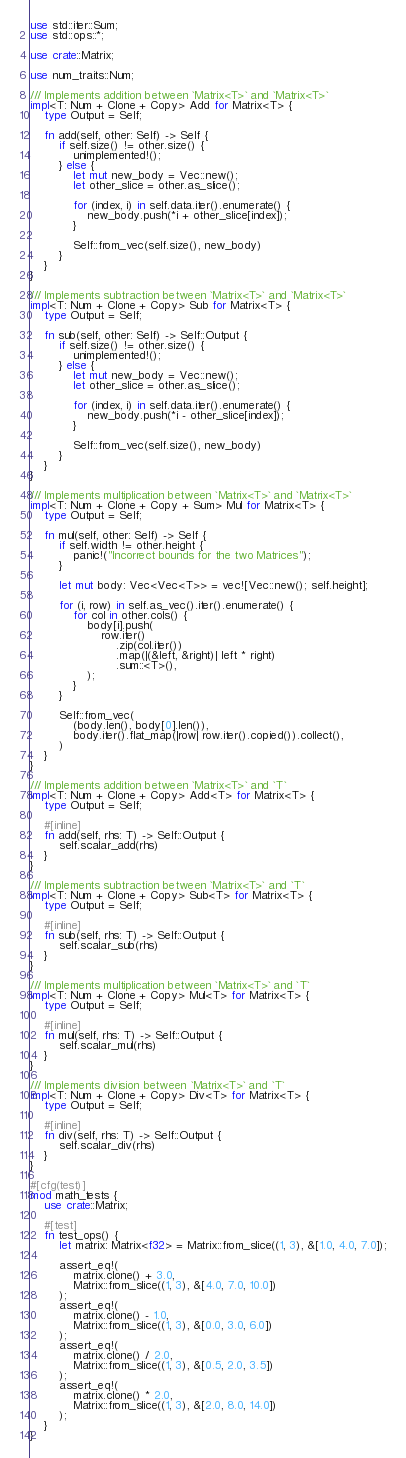<code> <loc_0><loc_0><loc_500><loc_500><_Rust_>use std::iter::Sum;
use std::ops::*;

use crate::Matrix;

use num_traits::Num;

/// Implements addition between `Matrix<T>` and `Matrix<T>`
impl<T: Num + Clone + Copy> Add for Matrix<T> {
    type Output = Self;

    fn add(self, other: Self) -> Self {
        if self.size() != other.size() {
            unimplemented!();
        } else {
            let mut new_body = Vec::new();
            let other_slice = other.as_slice();

            for (index, i) in self.data.iter().enumerate() {
                new_body.push(*i + other_slice[index]);
            }

            Self::from_vec(self.size(), new_body)
        }
    }
}

/// Implements subtraction between `Matrix<T>` and `Matrix<T>`
impl<T: Num + Clone + Copy> Sub for Matrix<T> {
    type Output = Self;

    fn sub(self, other: Self) -> Self::Output {
        if self.size() != other.size() {
            unimplemented!();
        } else {
            let mut new_body = Vec::new();
            let other_slice = other.as_slice();

            for (index, i) in self.data.iter().enumerate() {
                new_body.push(*i - other_slice[index]);
            }

            Self::from_vec(self.size(), new_body)
        }
    }
}

/// Implements multiplication between `Matrix<T>` and `Matrix<T>`
impl<T: Num + Clone + Copy + Sum> Mul for Matrix<T> {
    type Output = Self;

    fn mul(self, other: Self) -> Self {
        if self.width != other.height {
            panic!("Incorrect bounds for the two Matrices");
        }

        let mut body: Vec<Vec<T>> = vec![Vec::new(); self.height];

        for (i, row) in self.as_vec().iter().enumerate() {
            for col in other.cols() {
                body[i].push(
                    row.iter()
                        .zip(col.iter())
                        .map(|(&left, &right)| left * right)
                        .sum::<T>(),
                );
            }
        }

        Self::from_vec(
            (body.len(), body[0].len()),
            body.iter().flat_map(|row| row.iter().copied()).collect(),
        )
    }
}

/// Implements addition between `Matrix<T>` and `T`
impl<T: Num + Clone + Copy> Add<T> for Matrix<T> {
    type Output = Self;

    #[inline]
    fn add(self, rhs: T) -> Self::Output {
        self.scalar_add(rhs)
    }
}

/// Implements subtraction between `Matrix<T>` and `T`
impl<T: Num + Clone + Copy> Sub<T> for Matrix<T> {
    type Output = Self;

    #[inline]
    fn sub(self, rhs: T) -> Self::Output {
        self.scalar_sub(rhs)
    }
}

/// Implements multiplication between `Matrix<T>` and `T`
impl<T: Num + Clone + Copy> Mul<T> for Matrix<T> {
    type Output = Self;

    #[inline]
    fn mul(self, rhs: T) -> Self::Output {
        self.scalar_mul(rhs)
    }
}

/// Implements division between `Matrix<T>` and `T`
impl<T: Num + Clone + Copy> Div<T> for Matrix<T> {
    type Output = Self;

    #[inline]
    fn div(self, rhs: T) -> Self::Output {
        self.scalar_div(rhs)
    }
}

#[cfg(test)]
mod math_tests {
    use crate::Matrix;

    #[test]
    fn test_ops() {
        let matrix: Matrix<f32> = Matrix::from_slice((1, 3), &[1.0, 4.0, 7.0]);

        assert_eq!(
            matrix.clone() + 3.0,
            Matrix::from_slice((1, 3), &[4.0, 7.0, 10.0])
        );
        assert_eq!(
            matrix.clone() - 1.0,
            Matrix::from_slice((1, 3), &[0.0, 3.0, 6.0])
        );
        assert_eq!(
            matrix.clone() / 2.0,
            Matrix::from_slice((1, 3), &[0.5, 2.0, 3.5])
        );
        assert_eq!(
            matrix.clone() * 2.0,
            Matrix::from_slice((1, 3), &[2.0, 8.0, 14.0])
        );
    }
}
</code> 